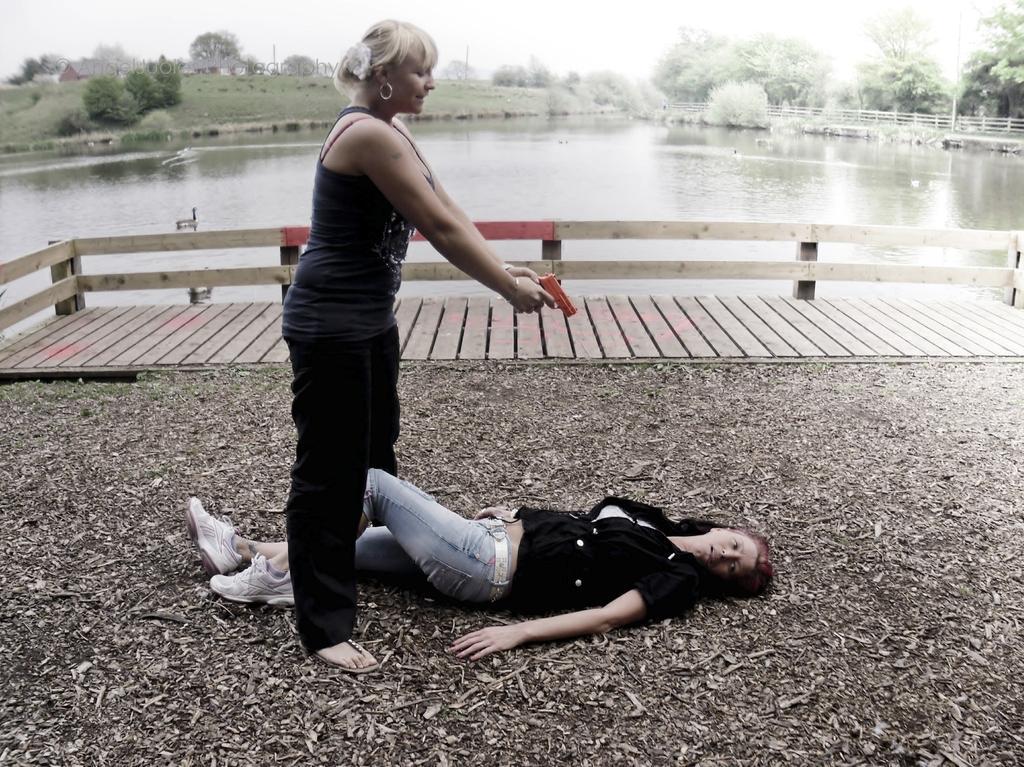In one or two sentences, can you explain what this image depicts? In this image I can see a woman standing and a woman lying on the ground. In the background, I can see the water, trees and the sky. 